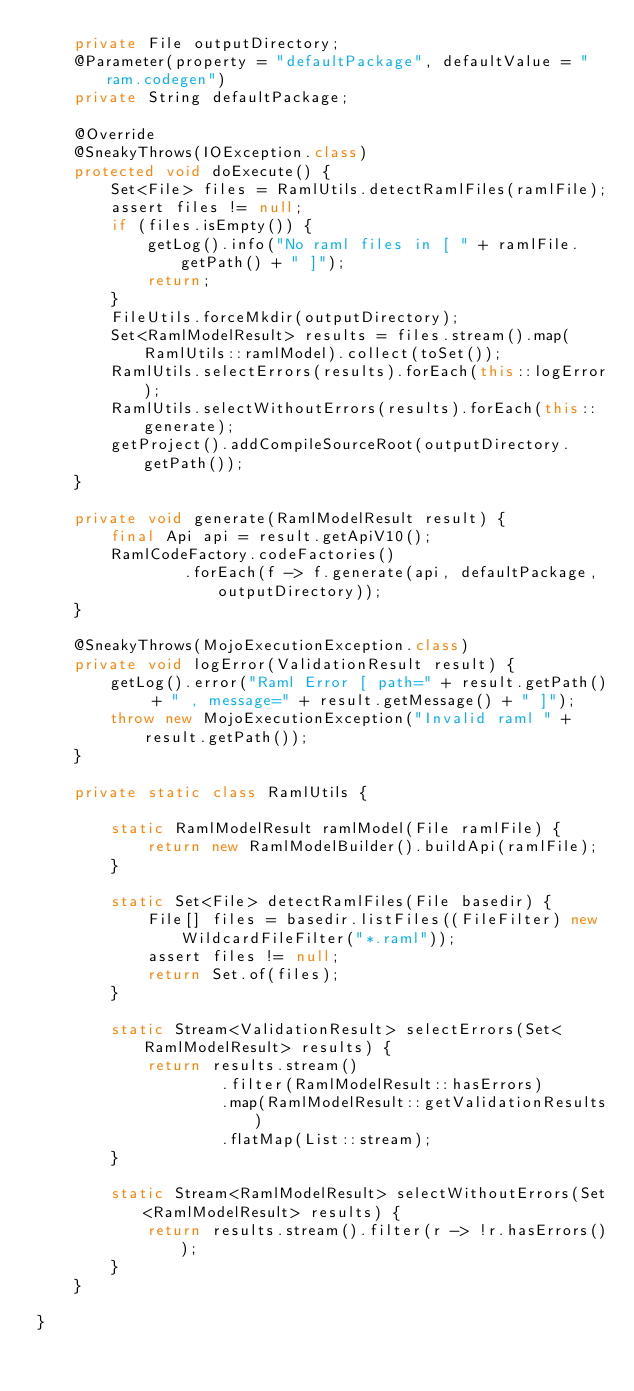Convert code to text. <code><loc_0><loc_0><loc_500><loc_500><_Java_>    private File outputDirectory;
    @Parameter(property = "defaultPackage", defaultValue = "ram.codegen")
    private String defaultPackage;

    @Override
    @SneakyThrows(IOException.class)
    protected void doExecute() {
        Set<File> files = RamlUtils.detectRamlFiles(ramlFile);
        assert files != null;
        if (files.isEmpty()) {
            getLog().info("No raml files in [ " + ramlFile.getPath() + " ]");
            return;
        }
        FileUtils.forceMkdir(outputDirectory);
        Set<RamlModelResult> results = files.stream().map(RamlUtils::ramlModel).collect(toSet());
        RamlUtils.selectErrors(results).forEach(this::logError);
        RamlUtils.selectWithoutErrors(results).forEach(this::generate);
        getProject().addCompileSourceRoot(outputDirectory.getPath());
    }

    private void generate(RamlModelResult result) {
        final Api api = result.getApiV10();
        RamlCodeFactory.codeFactories()
                .forEach(f -> f.generate(api, defaultPackage, outputDirectory));
    }

    @SneakyThrows(MojoExecutionException.class)
    private void logError(ValidationResult result) {
        getLog().error("Raml Error [ path=" + result.getPath() + " , message=" + result.getMessage() + " ]");
        throw new MojoExecutionException("Invalid raml " + result.getPath());
    }

    private static class RamlUtils {

        static RamlModelResult ramlModel(File ramlFile) {
            return new RamlModelBuilder().buildApi(ramlFile);
        }

        static Set<File> detectRamlFiles(File basedir) {
            File[] files = basedir.listFiles((FileFilter) new WildcardFileFilter("*.raml"));
            assert files != null;
            return Set.of(files);
        }

        static Stream<ValidationResult> selectErrors(Set<RamlModelResult> results) {
            return results.stream()
                    .filter(RamlModelResult::hasErrors)
                    .map(RamlModelResult::getValidationResults)
                    .flatMap(List::stream);
        }

        static Stream<RamlModelResult> selectWithoutErrors(Set<RamlModelResult> results) {
            return results.stream().filter(r -> !r.hasErrors());
        }
    }

}
</code> 